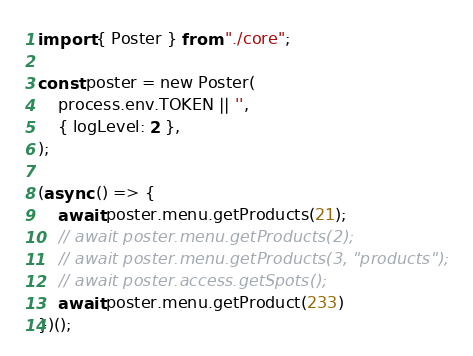Convert code to text. <code><loc_0><loc_0><loc_500><loc_500><_TypeScript_>import { Poster } from "./core";

const poster = new Poster(
    process.env.TOKEN || '',
    { logLevel: 2 },
);

(async () => {
    await poster.menu.getProducts(21);
    // await poster.menu.getProducts(2);
    // await poster.menu.getProducts(3, "products");
    // await poster.access.getSpots();
    await poster.menu.getProduct(233)
})();
</code> 